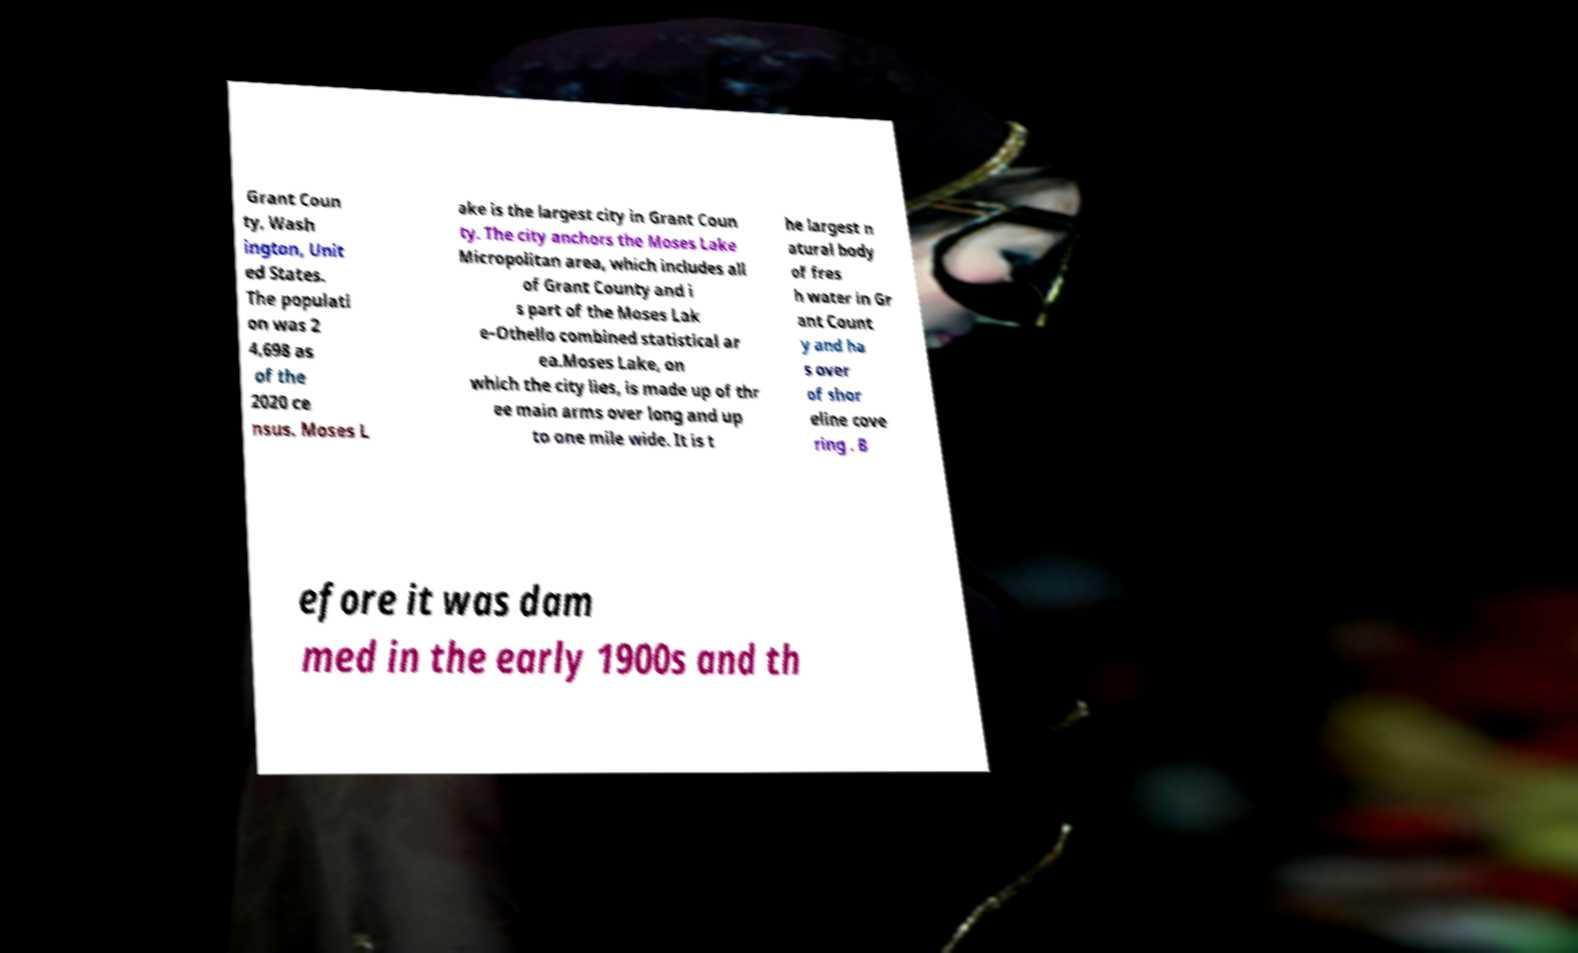There's text embedded in this image that I need extracted. Can you transcribe it verbatim? Grant Coun ty, Wash ington, Unit ed States. The populati on was 2 4,698 as of the 2020 ce nsus. Moses L ake is the largest city in Grant Coun ty. The city anchors the Moses Lake Micropolitan area, which includes all of Grant County and i s part of the Moses Lak e–Othello combined statistical ar ea.Moses Lake, on which the city lies, is made up of thr ee main arms over long and up to one mile wide. It is t he largest n atural body of fres h water in Gr ant Count y and ha s over of shor eline cove ring . B efore it was dam med in the early 1900s and th 